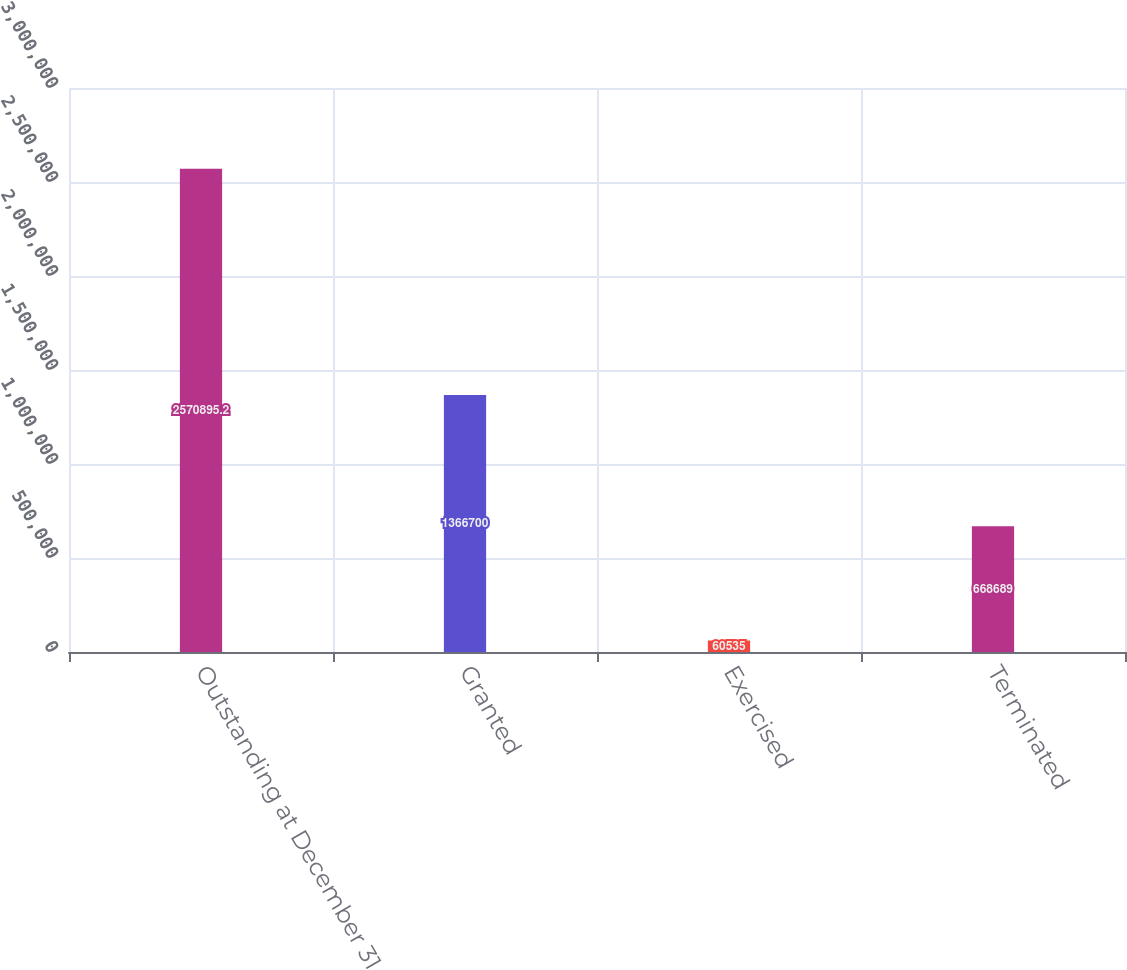Convert chart to OTSL. <chart><loc_0><loc_0><loc_500><loc_500><bar_chart><fcel>Outstanding at December 31<fcel>Granted<fcel>Exercised<fcel>Terminated<nl><fcel>2.5709e+06<fcel>1.3667e+06<fcel>60535<fcel>668689<nl></chart> 